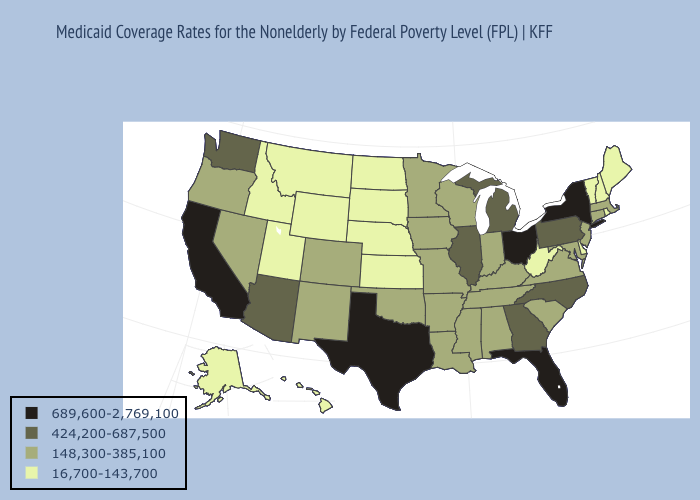Does Delaware have the lowest value in the USA?
Be succinct. Yes. Name the states that have a value in the range 689,600-2,769,100?
Concise answer only. California, Florida, New York, Ohio, Texas. Does Louisiana have the highest value in the South?
Quick response, please. No. How many symbols are there in the legend?
Answer briefly. 4. Name the states that have a value in the range 148,300-385,100?
Concise answer only. Alabama, Arkansas, Colorado, Connecticut, Indiana, Iowa, Kentucky, Louisiana, Maryland, Massachusetts, Minnesota, Mississippi, Missouri, Nevada, New Jersey, New Mexico, Oklahoma, Oregon, South Carolina, Tennessee, Virginia, Wisconsin. Among the states that border Mississippi , which have the highest value?
Write a very short answer. Alabama, Arkansas, Louisiana, Tennessee. Name the states that have a value in the range 689,600-2,769,100?
Quick response, please. California, Florida, New York, Ohio, Texas. Among the states that border New York , does Pennsylvania have the lowest value?
Keep it brief. No. Which states have the lowest value in the South?
Give a very brief answer. Delaware, West Virginia. Does Ohio have the highest value in the USA?
Quick response, please. Yes. Does North Dakota have the lowest value in the USA?
Concise answer only. Yes. What is the value of Massachusetts?
Be succinct. 148,300-385,100. Does Arkansas have a higher value than South Dakota?
Write a very short answer. Yes. Does Virginia have the lowest value in the USA?
Short answer required. No. 